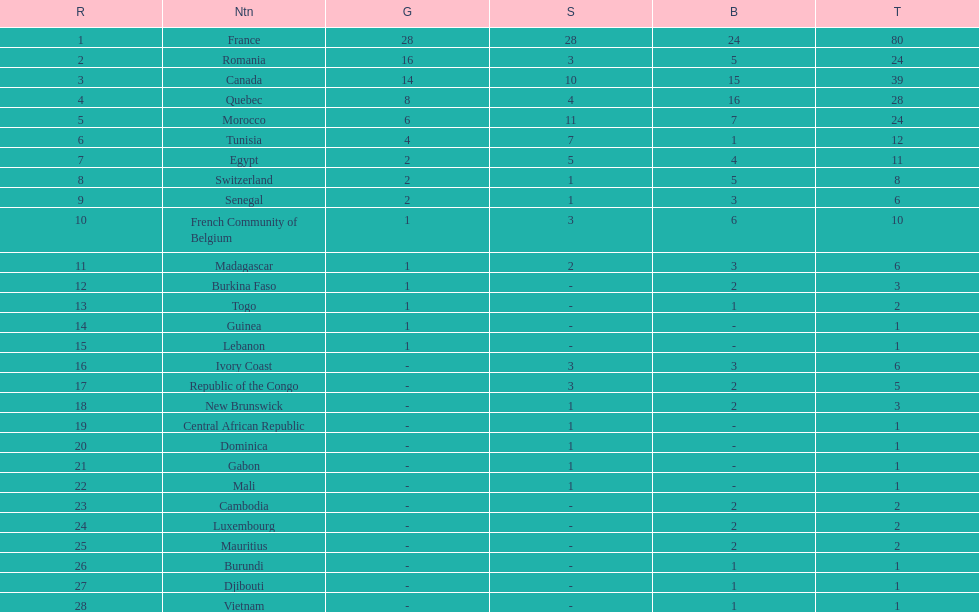How many more medals did egypt win than ivory coast? 5. 